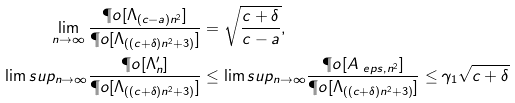Convert formula to latex. <formula><loc_0><loc_0><loc_500><loc_500>\lim _ { n \to \infty } \frac { \P o [ \Lambda _ { ( c - a ) n ^ { 2 } } ] } { \P o [ \Lambda _ { ( ( c + \delta ) n ^ { 2 } + 3 ) } ] } & = \sqrt { \frac { c + \delta } { c - a } } , \\ \lim s u p _ { n \to \infty } \frac { \P o [ \Lambda ^ { \prime } _ { n } ] } { \P o [ \Lambda _ { ( ( c + \delta ) n ^ { 2 } + 3 ) } ] } & \leq \lim s u p _ { n \to \infty } \frac { \P o [ A _ { \ e p s , n ^ { 2 } } ] } { \P o [ \Lambda _ { ( ( c + \delta ) n ^ { 2 } + 3 ) } ] } \leq \gamma _ { 1 } \sqrt { c + \delta }</formula> 